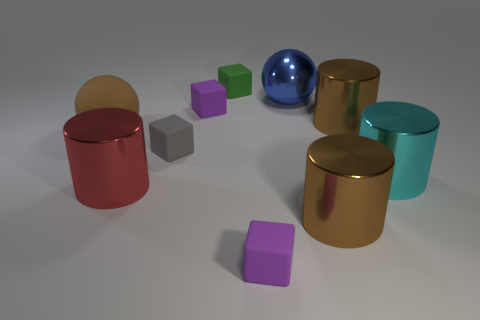Add 6 big brown metal things. How many big brown metal things exist? 8 Subtract all green blocks. How many blocks are left? 3 Subtract all small gray matte blocks. How many blocks are left? 3 Subtract 0 brown blocks. How many objects are left? 10 Subtract all blocks. How many objects are left? 6 Subtract 1 cylinders. How many cylinders are left? 3 Subtract all cyan cylinders. Subtract all gray balls. How many cylinders are left? 3 Subtract all green cylinders. How many gray balls are left? 0 Subtract all metallic things. Subtract all small yellow rubber cubes. How many objects are left? 5 Add 9 blue balls. How many blue balls are left? 10 